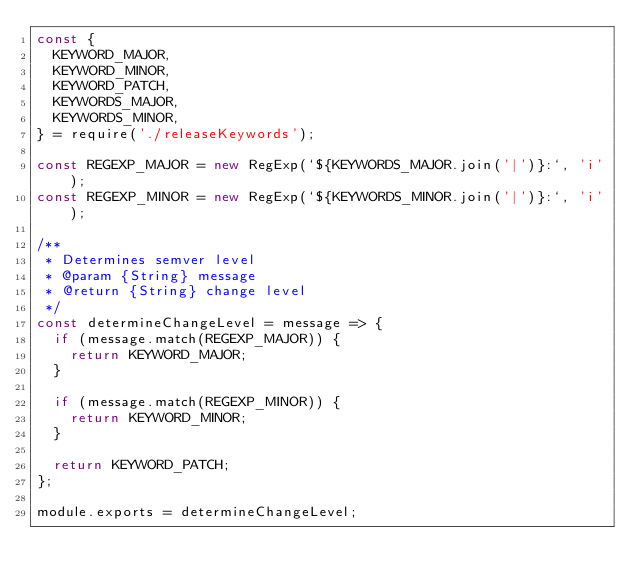<code> <loc_0><loc_0><loc_500><loc_500><_JavaScript_>const {
  KEYWORD_MAJOR,
  KEYWORD_MINOR,
  KEYWORD_PATCH,
  KEYWORDS_MAJOR,
  KEYWORDS_MINOR,
} = require('./releaseKeywords');

const REGEXP_MAJOR = new RegExp(`${KEYWORDS_MAJOR.join('|')}:`, 'i');
const REGEXP_MINOR = new RegExp(`${KEYWORDS_MINOR.join('|')}:`, 'i');

/**
 * Determines semver level
 * @param {String} message
 * @return {String} change level
 */
const determineChangeLevel = message => {
  if (message.match(REGEXP_MAJOR)) {
    return KEYWORD_MAJOR;
  }

  if (message.match(REGEXP_MINOR)) {
    return KEYWORD_MINOR;
  }

  return KEYWORD_PATCH;
};

module.exports = determineChangeLevel;
</code> 